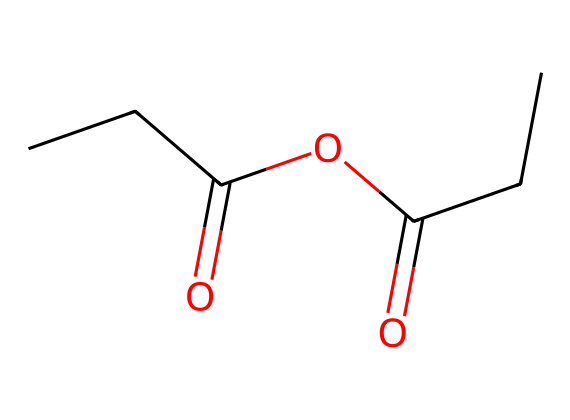What is the name of this chemical? The SMILES notation CCC(=O)OC(=O)CC indicates a compound with a propionic structure and an anhydride functional group. Therefore, the name is derived from propionic acid.
Answer: propionic anhydride How many carbon atoms are in the molecular structure? The SMILES shows "CCC" for three carbons in the propionic part and "CC" again for two more, totaling five carbon atoms.
Answer: five How many oxygen atoms are present in this structure? The notation has "O" twice, indicating there are two oxygen atoms in the anhydride part, leading to a total of two oxygen atoms.
Answer: two What functional group is present in this molecule? The structure highlights the presence of an anhydride due to the "OC(=O)" segment, which denotes the linkage of two acyl groups with one oxygen.
Answer: anhydride What type of reaction would propionic anhydride most likely undergo? Anhydrides are known to participate in acylation reactions due to their reactivity with nucleophiles, like alcohols or amines, forming esters or amides.
Answer: acylation reaction What is the significance of propionic anhydride in food preservation? Propionic anhydride can be used to form propionic acid, which is a known preservative, providing a way to inhibit mold and bacteria in food products.
Answer: food preservative 